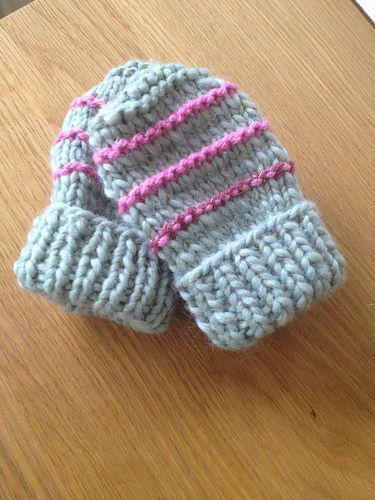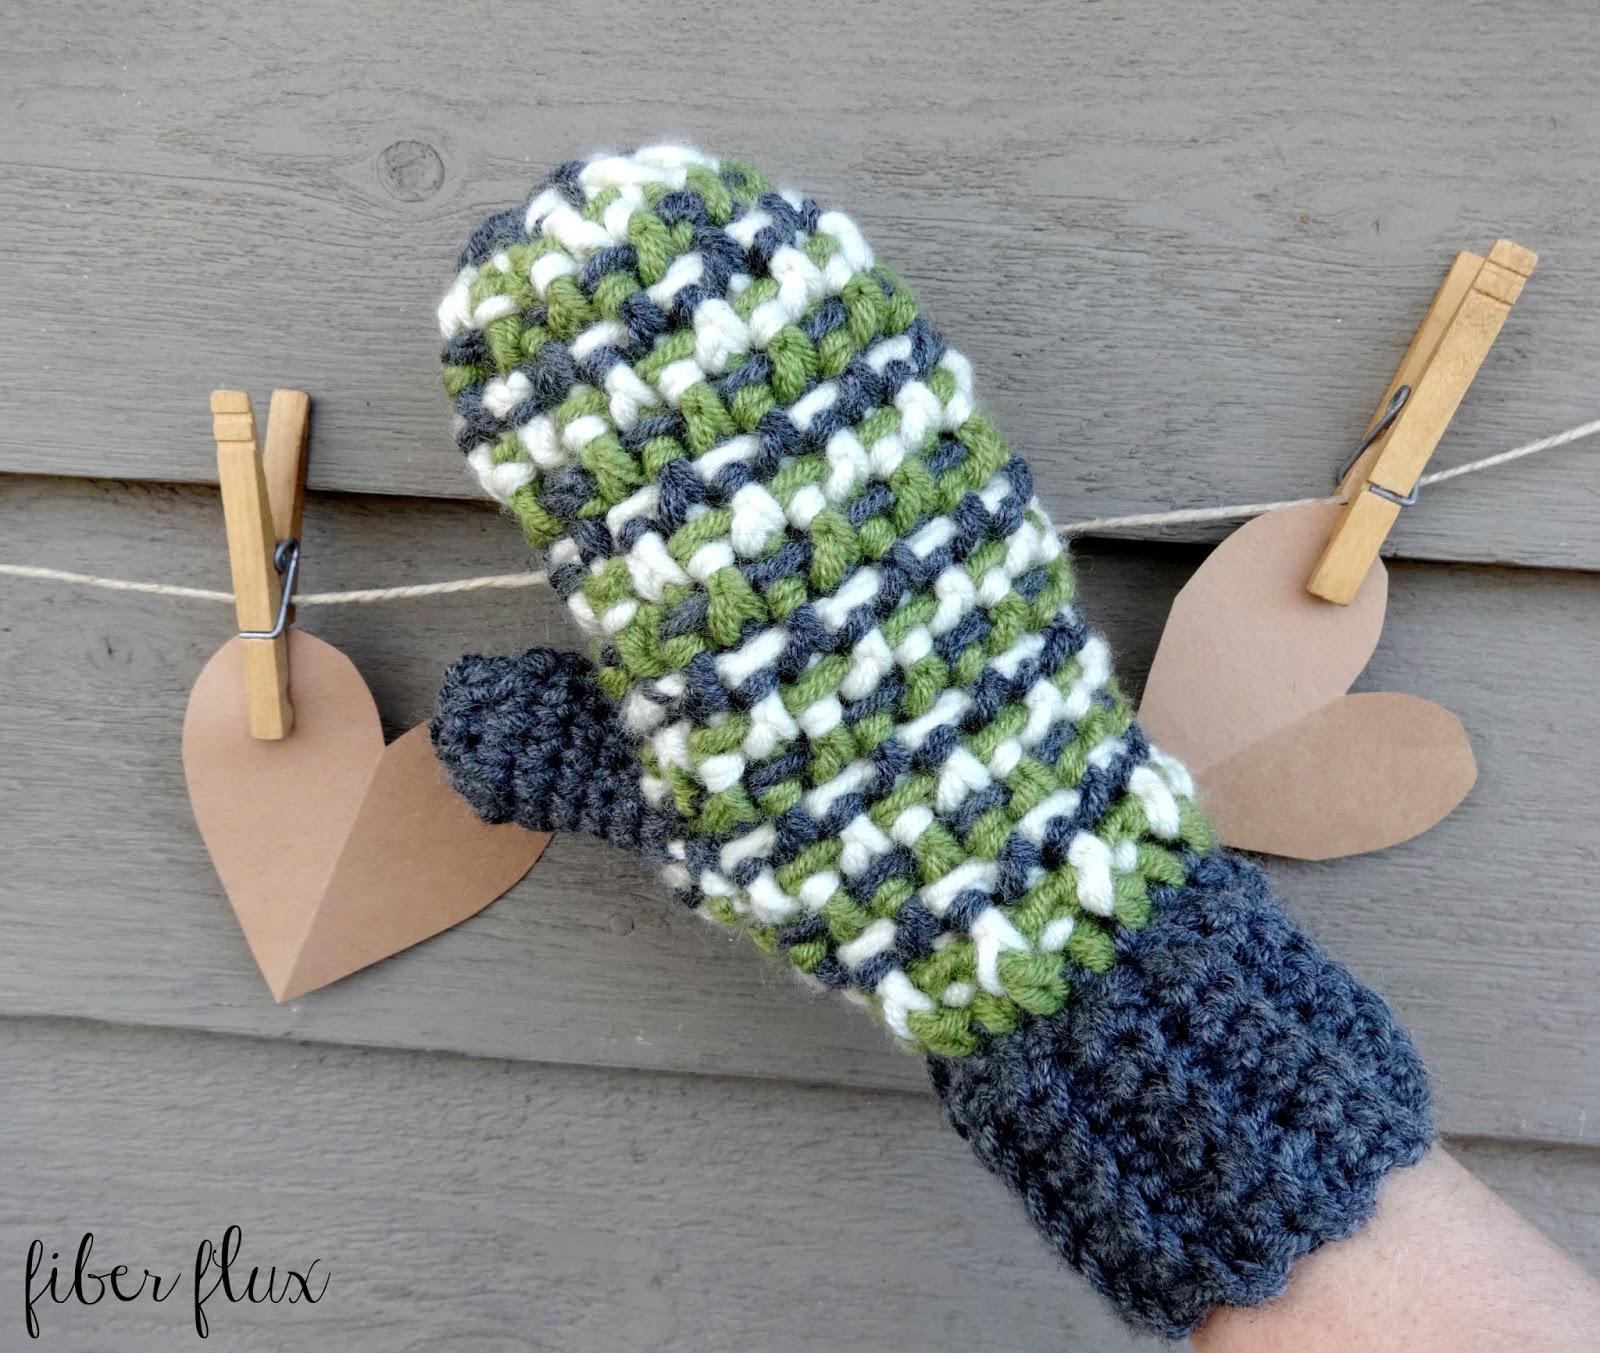The first image is the image on the left, the second image is the image on the right. Given the left and right images, does the statement "The right image contains at least two mittens." hold true? Answer yes or no. No. The first image is the image on the left, the second image is the image on the right. For the images shown, is this caption "One image shows at least one knitted mitten modelled on a human hand." true? Answer yes or no. Yes. 